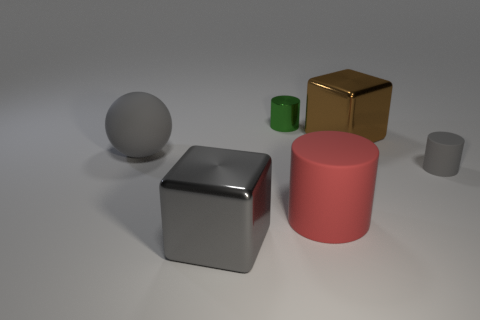Add 1 big red objects. How many objects exist? 7 Subtract all tiny metallic cylinders. How many cylinders are left? 2 Subtract all red cylinders. How many cylinders are left? 2 Subtract all blocks. How many objects are left? 4 Subtract 2 cylinders. How many cylinders are left? 1 Subtract all cyan spheres. Subtract all yellow cylinders. How many spheres are left? 1 Subtract all tiny gray matte things. Subtract all small green cylinders. How many objects are left? 4 Add 5 large matte things. How many large matte things are left? 7 Add 5 green matte blocks. How many green matte blocks exist? 5 Subtract 0 purple blocks. How many objects are left? 6 